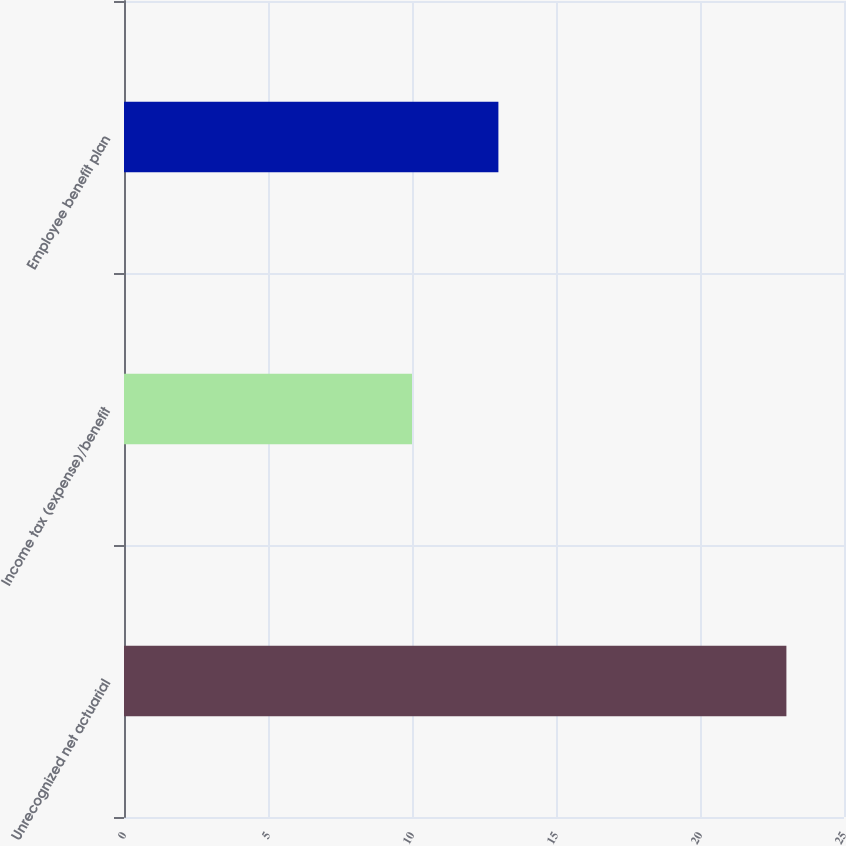Convert chart. <chart><loc_0><loc_0><loc_500><loc_500><bar_chart><fcel>Unrecognized net actuarial<fcel>Income tax (expense)/benefit<fcel>Employee benefit plan<nl><fcel>23<fcel>10<fcel>13<nl></chart> 